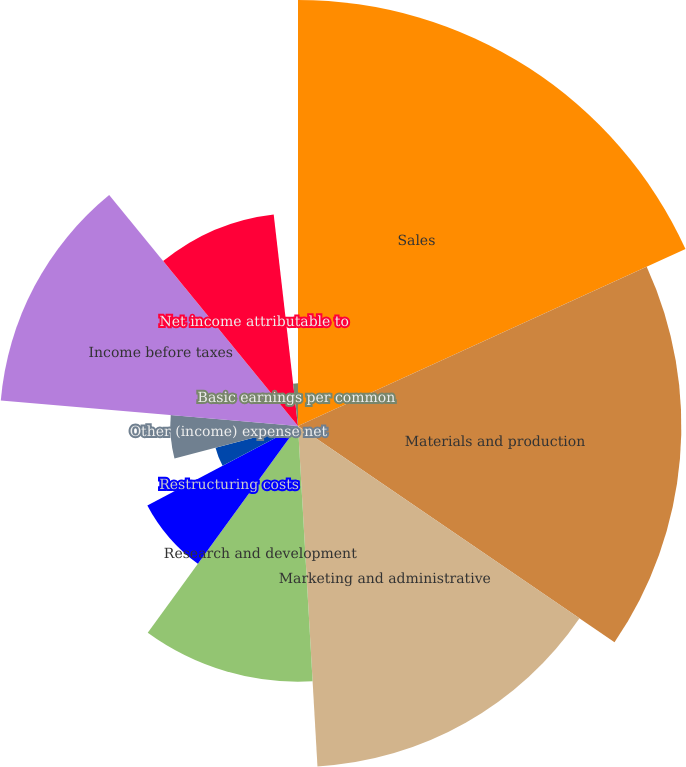<chart> <loc_0><loc_0><loc_500><loc_500><pie_chart><fcel>Sales<fcel>Materials and production<fcel>Marketing and administrative<fcel>Research and development<fcel>Restructuring costs<fcel>Equity income from affiliates<fcel>Other (income) expense net<fcel>Income before taxes<fcel>Net income attributable to<fcel>Basic earnings per common<nl><fcel>18.18%<fcel>16.36%<fcel>14.55%<fcel>10.91%<fcel>7.27%<fcel>3.64%<fcel>5.45%<fcel>12.73%<fcel>9.09%<fcel>1.82%<nl></chart> 